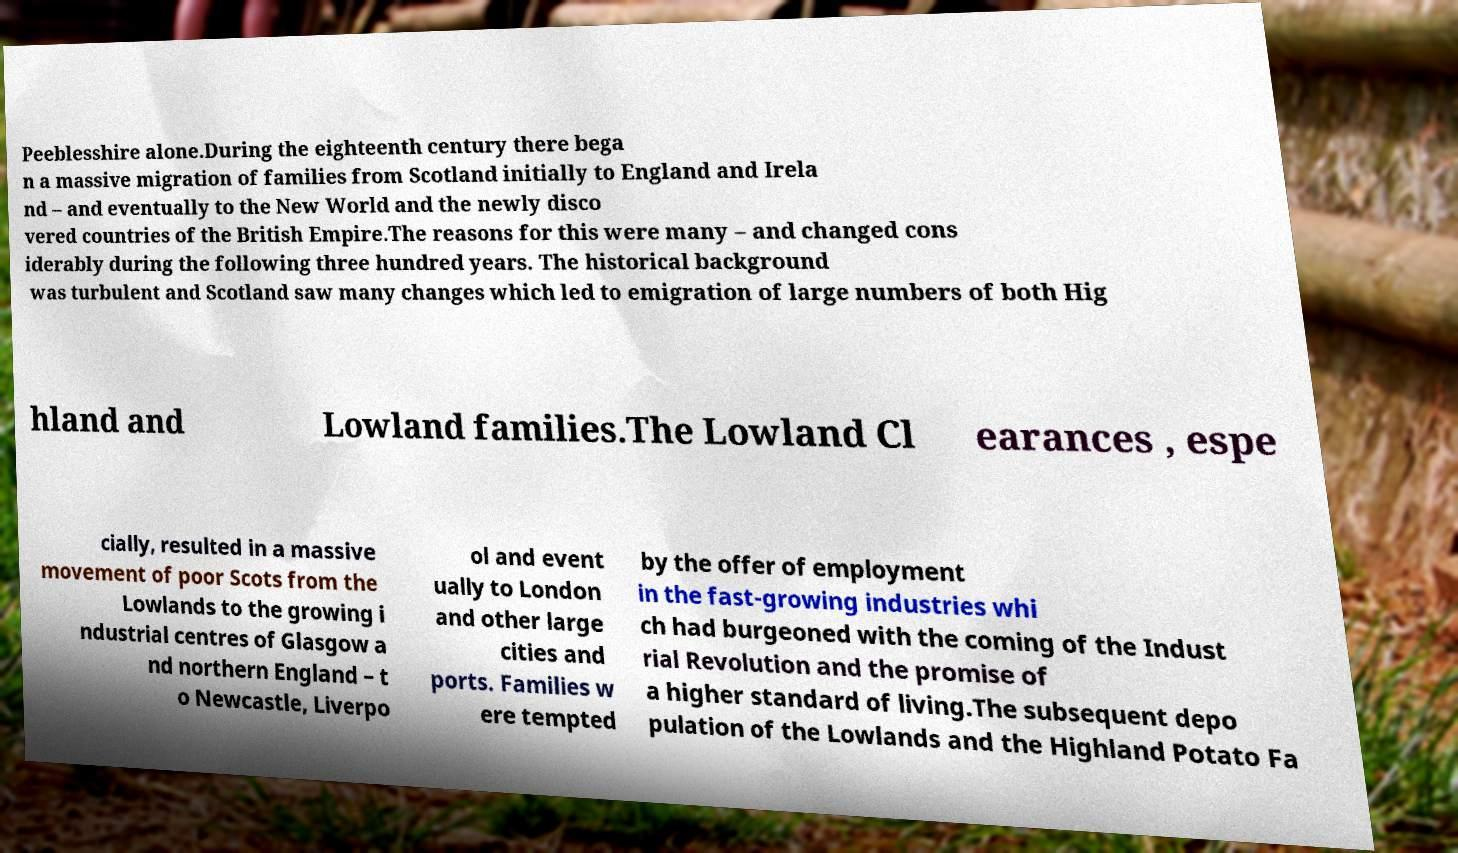Please read and relay the text visible in this image. What does it say? Peeblesshire alone.During the eighteenth century there bega n a massive migration of families from Scotland initially to England and Irela nd – and eventually to the New World and the newly disco vered countries of the British Empire.The reasons for this were many – and changed cons iderably during the following three hundred years. The historical background was turbulent and Scotland saw many changes which led to emigration of large numbers of both Hig hland and Lowland families.The Lowland Cl earances , espe cially, resulted in a massive movement of poor Scots from the Lowlands to the growing i ndustrial centres of Glasgow a nd northern England – t o Newcastle, Liverpo ol and event ually to London and other large cities and ports. Families w ere tempted by the offer of employment in the fast-growing industries whi ch had burgeoned with the coming of the Indust rial Revolution and the promise of a higher standard of living.The subsequent depo pulation of the Lowlands and the Highland Potato Fa 